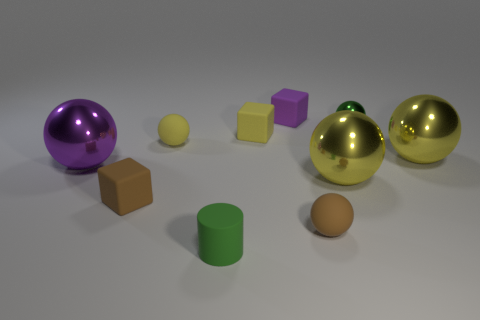Subtract all small green metal spheres. How many spheres are left? 5 Subtract 6 spheres. How many spheres are left? 0 Subtract all tiny cubes. Subtract all big purple shiny spheres. How many objects are left? 6 Add 1 green metal spheres. How many green metal spheres are left? 2 Add 3 brown things. How many brown things exist? 5 Subtract all yellow balls. How many balls are left? 3 Subtract 0 red cylinders. How many objects are left? 10 Subtract all cylinders. How many objects are left? 9 Subtract all red balls. Subtract all yellow cylinders. How many balls are left? 6 Subtract all blue cubes. How many brown balls are left? 1 